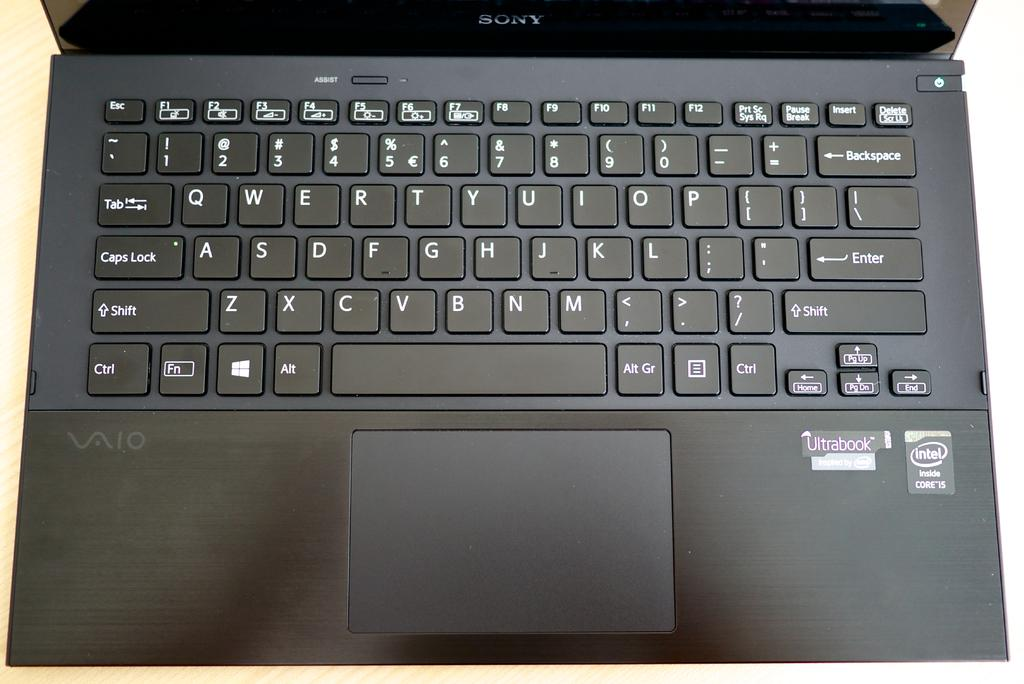<image>
Offer a succinct explanation of the picture presented. A Sony laptop is opened showing the keyboard. 